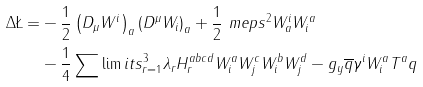Convert formula to latex. <formula><loc_0><loc_0><loc_500><loc_500>\Delta \L = & - \frac { 1 } { 2 } \left ( D _ { \mu } W ^ { i } \right ) _ { a } \left ( D ^ { \mu } W _ { i } \right ) _ { a } + \frac { 1 } { 2 } \ m e p s ^ { 2 } W ^ { i } _ { a } W _ { i } ^ { a } \\ & - \frac { 1 } { 4 } \sum \lim i t s _ { r = 1 } ^ { 3 } \lambda _ { r } H ^ { a b c d } _ { r } W _ { i } ^ { a } W _ { j } ^ { c } W _ { i } ^ { b } W _ { j } ^ { d } - g _ { y } \overline { q } \gamma ^ { i } W ^ { a } _ { i } T ^ { a } q</formula> 